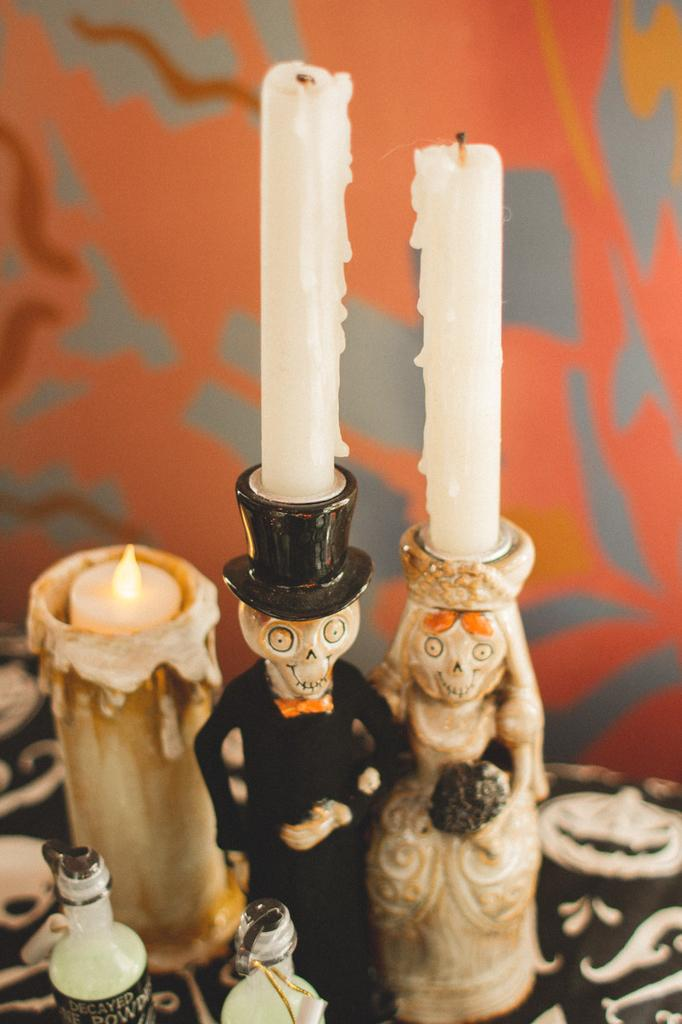What type of objects can be seen in the image? There are candles, bottles, and toys in the image. Where are these objects placed? All of these objects are placed on a platform. What can be seen in the background of the image? There is a wall visible in the background of the image. What sense is being used by the tramp in the image? There is no tramp present in the image, so it is not possible to determine which sense is being used. 